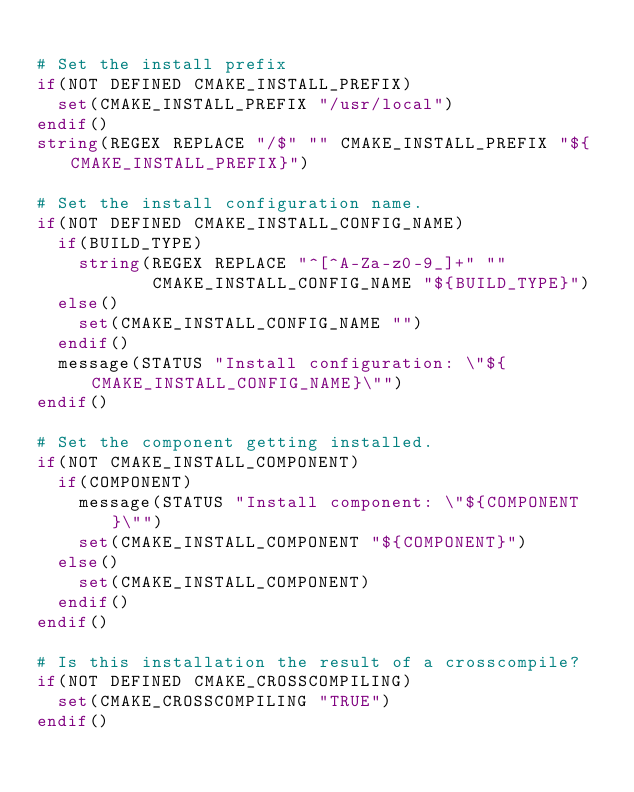Convert code to text. <code><loc_0><loc_0><loc_500><loc_500><_CMake_>
# Set the install prefix
if(NOT DEFINED CMAKE_INSTALL_PREFIX)
  set(CMAKE_INSTALL_PREFIX "/usr/local")
endif()
string(REGEX REPLACE "/$" "" CMAKE_INSTALL_PREFIX "${CMAKE_INSTALL_PREFIX}")

# Set the install configuration name.
if(NOT DEFINED CMAKE_INSTALL_CONFIG_NAME)
  if(BUILD_TYPE)
    string(REGEX REPLACE "^[^A-Za-z0-9_]+" ""
           CMAKE_INSTALL_CONFIG_NAME "${BUILD_TYPE}")
  else()
    set(CMAKE_INSTALL_CONFIG_NAME "")
  endif()
  message(STATUS "Install configuration: \"${CMAKE_INSTALL_CONFIG_NAME}\"")
endif()

# Set the component getting installed.
if(NOT CMAKE_INSTALL_COMPONENT)
  if(COMPONENT)
    message(STATUS "Install component: \"${COMPONENT}\"")
    set(CMAKE_INSTALL_COMPONENT "${COMPONENT}")
  else()
    set(CMAKE_INSTALL_COMPONENT)
  endif()
endif()

# Is this installation the result of a crosscompile?
if(NOT DEFINED CMAKE_CROSSCOMPILING)
  set(CMAKE_CROSSCOMPILING "TRUE")
endif()

</code> 